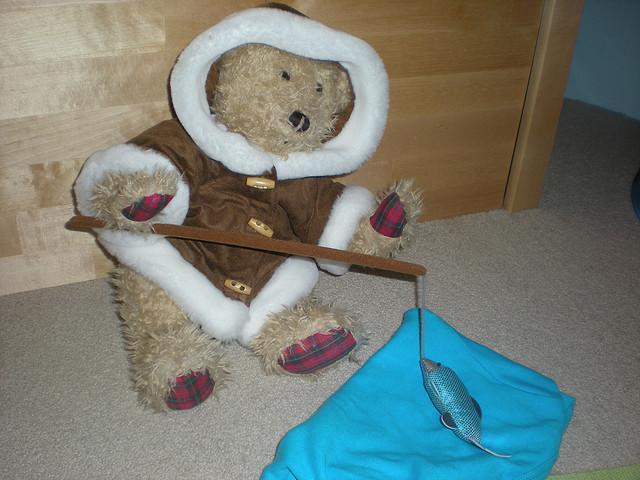How many people are in the picture?
Give a very brief answer. 0. 